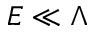<formula> <loc_0><loc_0><loc_500><loc_500>E \ll \Lambda</formula> 